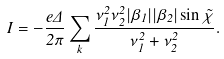<formula> <loc_0><loc_0><loc_500><loc_500>I = - \frac { e \Delta } { 2 \pi } \sum _ { k } \frac { \nu _ { 1 } ^ { 2 } \nu _ { 2 } ^ { 2 } | \beta _ { 1 } | | \beta _ { 2 } | \sin \tilde { \chi } } { \nu _ { 1 } ^ { 2 } + \nu _ { 2 } ^ { 2 } } .</formula> 